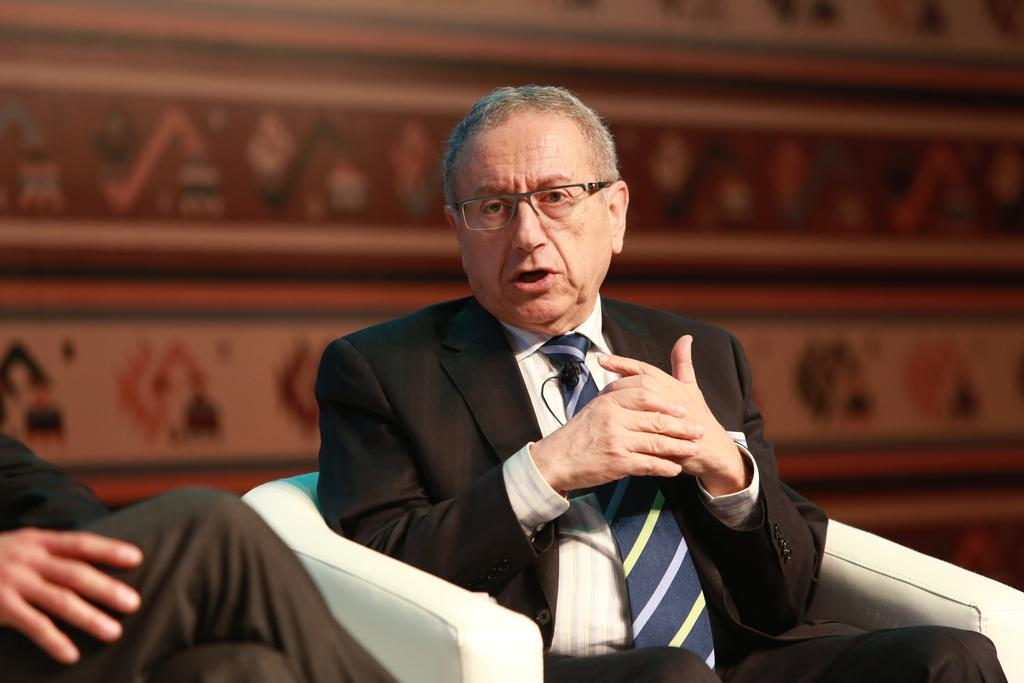How many people are in the image? There are two people sitting on chairs in the image. What is behind the people in the image? There is a wall behind the people. What can be seen on the wall? There is a painting on the wall. What type of lettuce is growing on the wall in the image? There is no lettuce present in the image; it features a painting on the wall. 